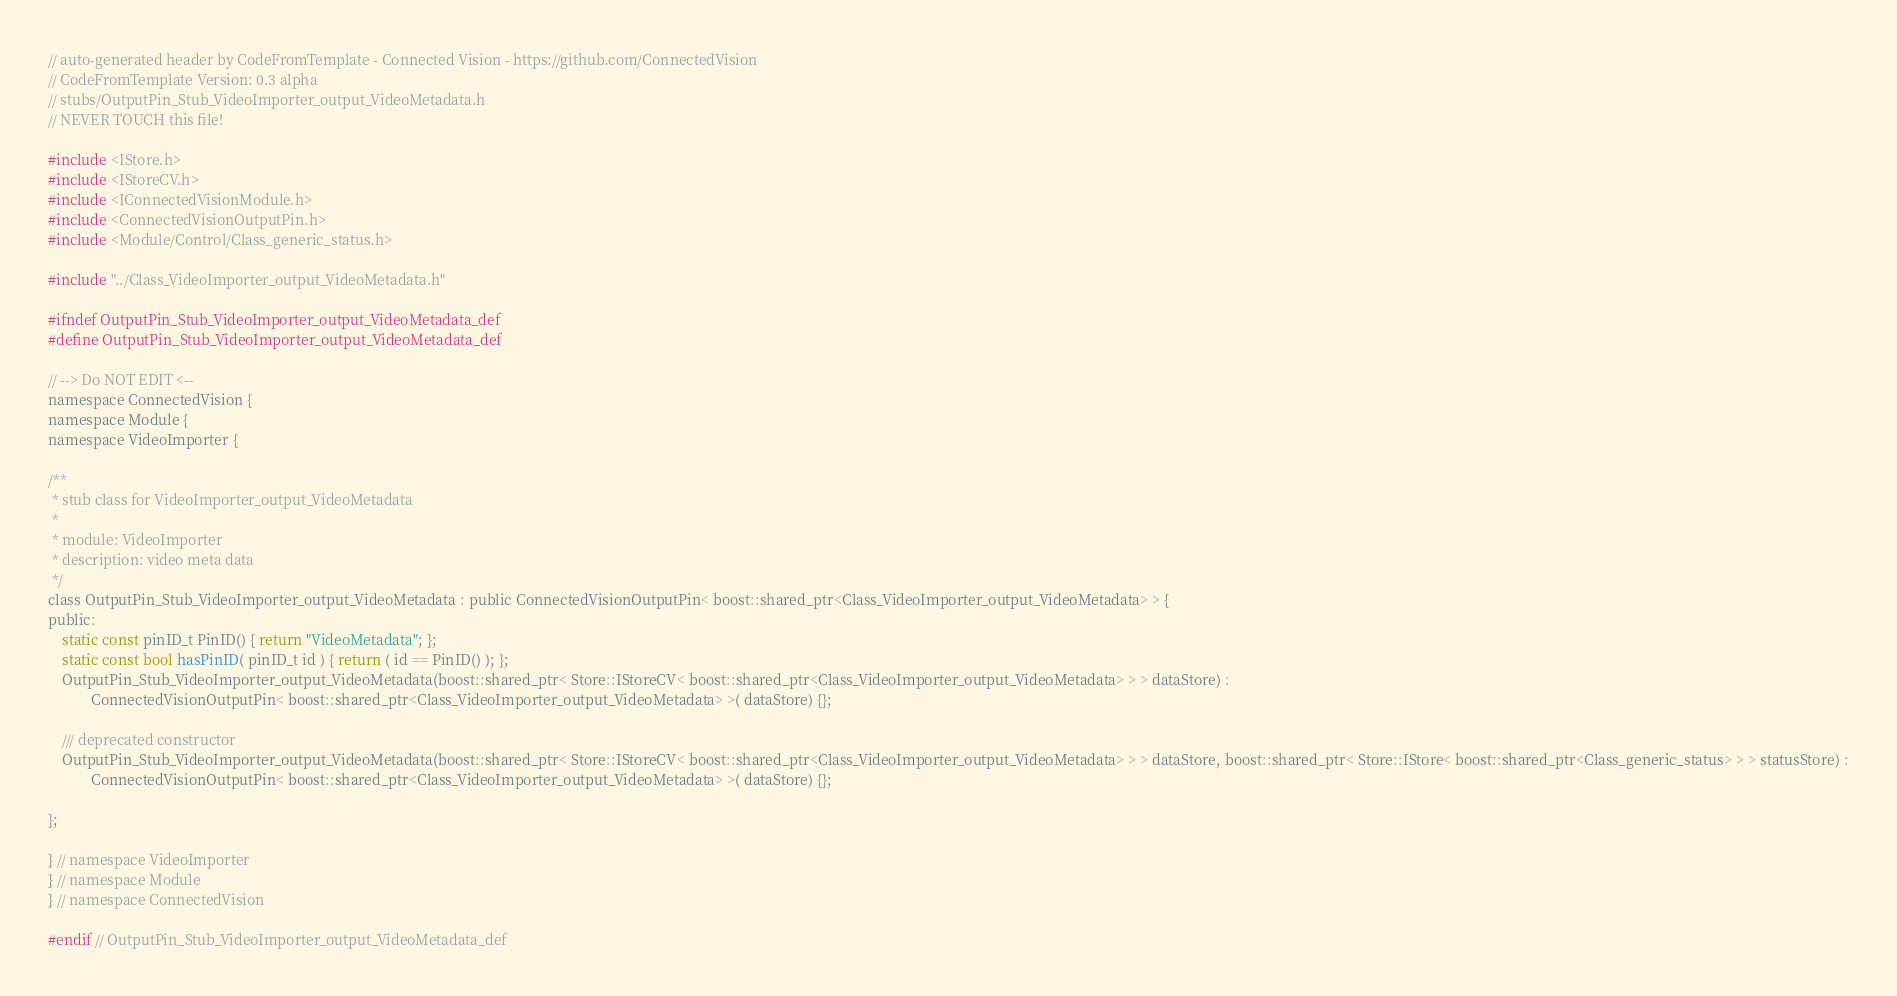<code> <loc_0><loc_0><loc_500><loc_500><_C_>// auto-generated header by CodeFromTemplate - Connected Vision - https://github.com/ConnectedVision
// CodeFromTemplate Version: 0.3 alpha
// stubs/OutputPin_Stub_VideoImporter_output_VideoMetadata.h
// NEVER TOUCH this file!

#include <IStore.h>
#include <IStoreCV.h>
#include <IConnectedVisionModule.h>
#include <ConnectedVisionOutputPin.h>
#include <Module/Control/Class_generic_status.h>

#include "../Class_VideoImporter_output_VideoMetadata.h"

#ifndef OutputPin_Stub_VideoImporter_output_VideoMetadata_def
#define OutputPin_Stub_VideoImporter_output_VideoMetadata_def

// --> Do NOT EDIT <--
namespace ConnectedVision {
namespace Module {
namespace VideoImporter {

/**
 * stub class for VideoImporter_output_VideoMetadata
 *
 * module: VideoImporter
 * description: video meta data
 */
class OutputPin_Stub_VideoImporter_output_VideoMetadata : public ConnectedVisionOutputPin< boost::shared_ptr<Class_VideoImporter_output_VideoMetadata> > {
public:
	static const pinID_t PinID() { return "VideoMetadata"; };
	static const bool hasPinID( pinID_t id ) { return ( id == PinID() ); };
	OutputPin_Stub_VideoImporter_output_VideoMetadata(boost::shared_ptr< Store::IStoreCV< boost::shared_ptr<Class_VideoImporter_output_VideoMetadata> > > dataStore) :
			ConnectedVisionOutputPin< boost::shared_ptr<Class_VideoImporter_output_VideoMetadata> >( dataStore) {};
	
	/// deprecated constructor
	OutputPin_Stub_VideoImporter_output_VideoMetadata(boost::shared_ptr< Store::IStoreCV< boost::shared_ptr<Class_VideoImporter_output_VideoMetadata> > > dataStore, boost::shared_ptr< Store::IStore< boost::shared_ptr<Class_generic_status> > > statusStore) :
			ConnectedVisionOutputPin< boost::shared_ptr<Class_VideoImporter_output_VideoMetadata> >( dataStore) {};

};

} // namespace VideoImporter
} // namespace Module
} // namespace ConnectedVision

#endif // OutputPin_Stub_VideoImporter_output_VideoMetadata_def</code> 